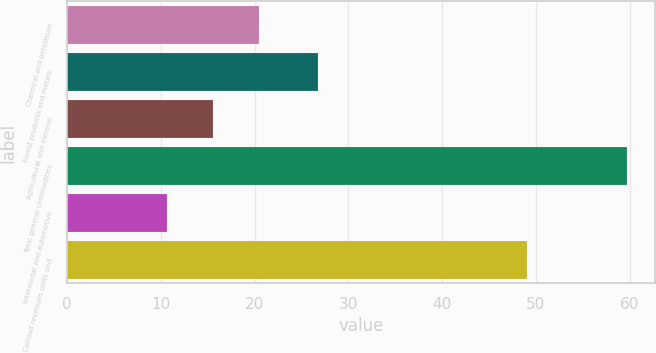Convert chart. <chart><loc_0><loc_0><loc_500><loc_500><bar_chart><fcel>Chemical and petroleum<fcel>Forest products and metals<fcel>Agricultural and mineral<fcel>Total general commodities<fcel>Intermodal and automotive<fcel>Carload revenues units and<nl><fcel>20.42<fcel>26.8<fcel>15.51<fcel>59.7<fcel>10.6<fcel>49.1<nl></chart> 